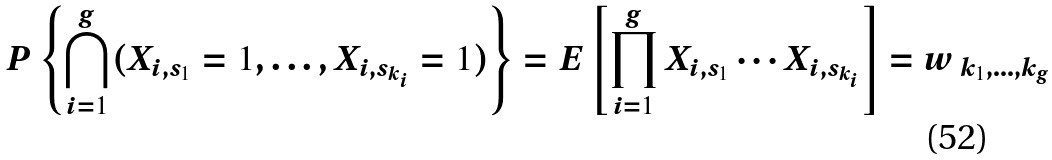<formula> <loc_0><loc_0><loc_500><loc_500>P \left \{ \bigcap _ { i = 1 } ^ { g } ( X _ { i , s _ { 1 } } = 1 , \dots , X _ { i , s _ { k _ { i } } } = 1 ) \right \} = E \left [ \prod _ { i = 1 } ^ { g } X _ { i , s _ { 1 } } \cdots X _ { i , s _ { k _ { i } } } \right ] = w \, _ { k _ { 1 } , \dots , k _ { g } }</formula> 